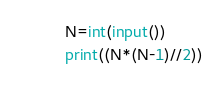<code> <loc_0><loc_0><loc_500><loc_500><_Python_>N=int(input())
print((N*(N-1)//2))</code> 